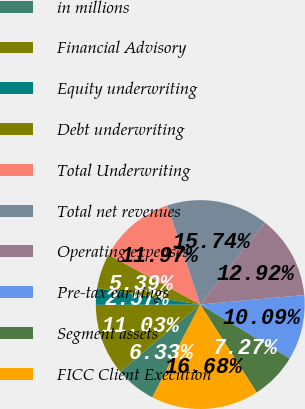Convert chart to OTSL. <chart><loc_0><loc_0><loc_500><loc_500><pie_chart><fcel>in millions<fcel>Financial Advisory<fcel>Equity underwriting<fcel>Debt underwriting<fcel>Total Underwriting<fcel>Total net revenues<fcel>Operating expenses<fcel>Pre-tax earnings<fcel>Segment assets<fcel>FICC Client Execution<nl><fcel>6.33%<fcel>11.03%<fcel>2.57%<fcel>5.39%<fcel>11.97%<fcel>15.73%<fcel>12.91%<fcel>10.09%<fcel>7.27%<fcel>16.67%<nl></chart> 